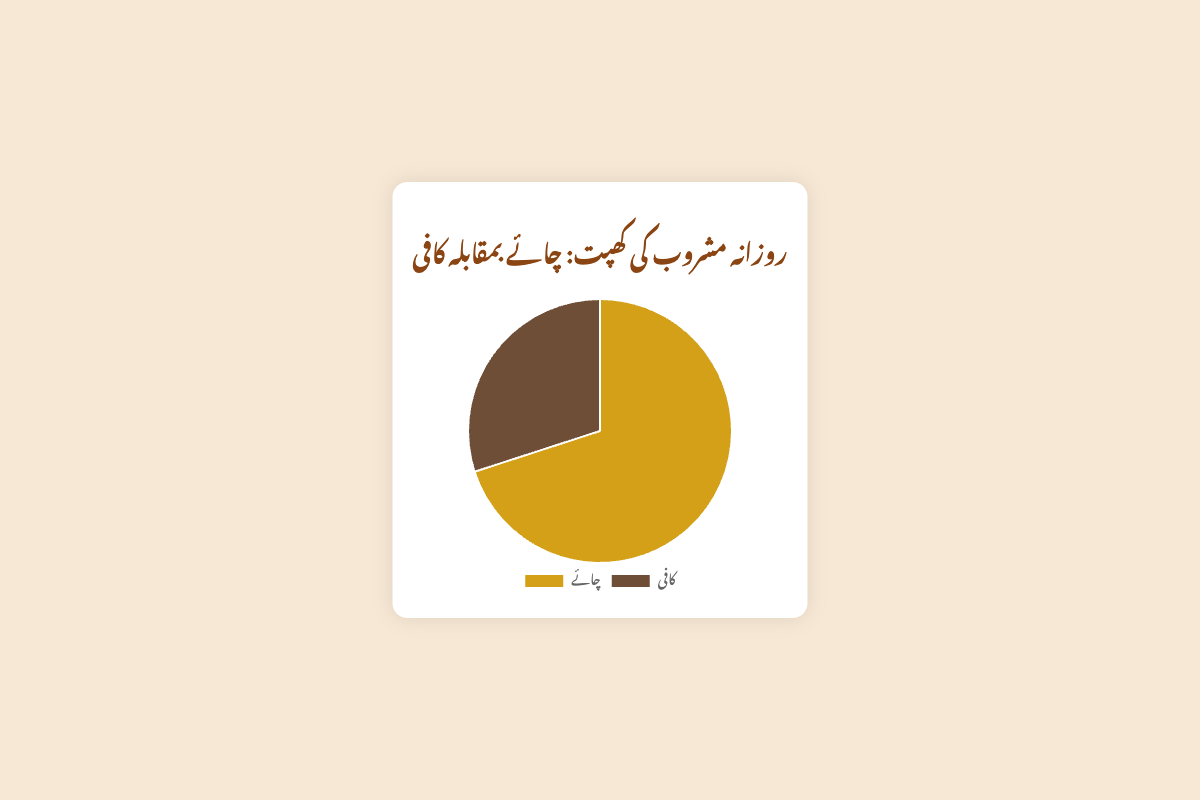کون سا مشروب زیادہ کا استعال ہوتا ہے؟ چائے کا استعال 70 فیصد ہے جبکہ کافی کا استعال 30 فیصد ہے، اس لئے چائے زیادہ استعمال ہوتی ہے
Answer: چائے چائے اور کافی کے استمال میں کتنا فرق ہے؟ چائے کا استعمال 70 فیصد ہے اور کافی کا 30 فیصد۔ دو فیصد کے فرق کو نکالنے کے لئے، (70 - 30) = 40 فیصد فرق ہے
Answer: 40 فیصد کیا چائے کا استعمال کافی سے زیادہ ہے؟ جی ہاں، چائے کا استعمال 70 فیصد ہے جو کہ کافی کے 30 فیصد سے زیادہ ہے
Answer: نعم گراف میں کون سے دو رنگ استعمال ہوئے ہیں؟ چائے کے لئے پیلا رنگ اور کافی کے لئے گہرا بھورا رنگ استعمال ہوا ہے
Answer: پیلا اور بھورا کل مشروبات کے کتنے فیصد حصے کا استعمال ہوتا ہے؟ کل مشروبات کے 100 فیصد حصے میں سے 70 فیصد چائے اور 30 فیصد کافی کا استعمال ہوتا ہے، جو کہ تمام 100 فیصد ہوتا ہے
Answer: 100 فیصد 